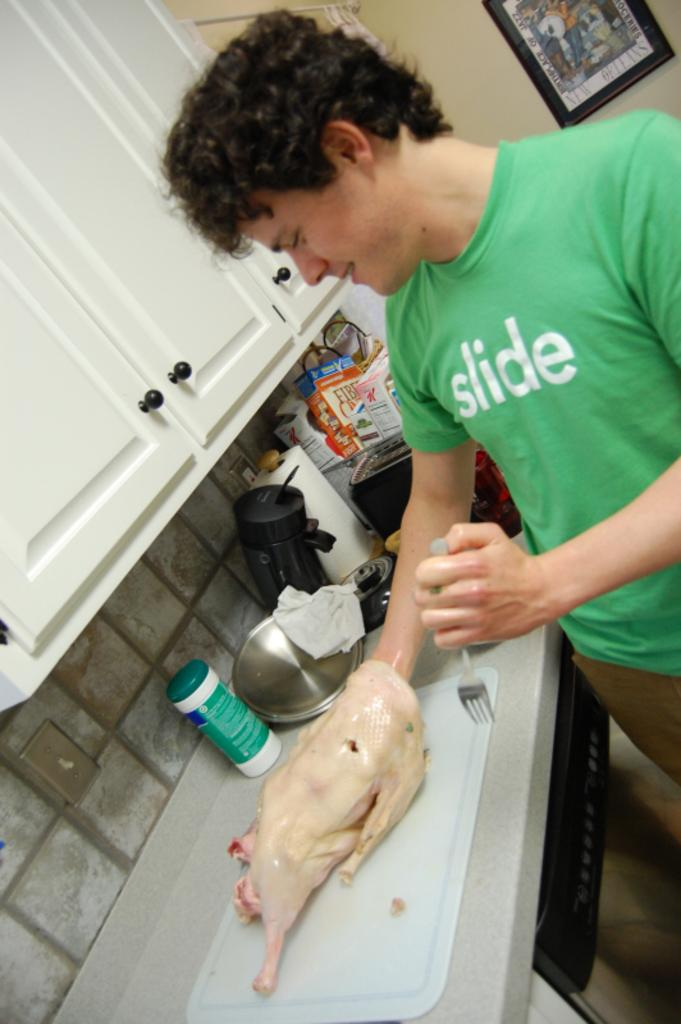<image>
Describe the image concisely. A man is preparing poultry while wearing a green shirt that says slide on it. 